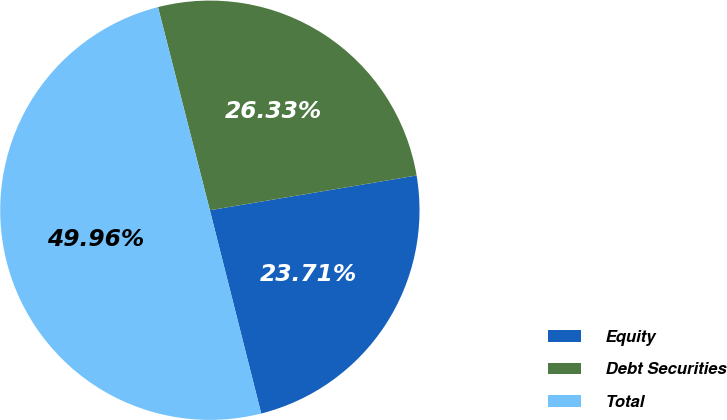Convert chart to OTSL. <chart><loc_0><loc_0><loc_500><loc_500><pie_chart><fcel>Equity<fcel>Debt Securities<fcel>Total<nl><fcel>23.71%<fcel>26.33%<fcel>49.96%<nl></chart> 